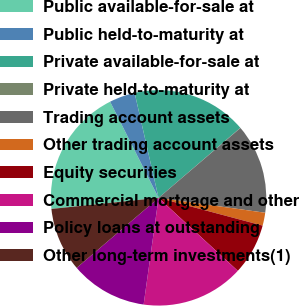<chart> <loc_0><loc_0><loc_500><loc_500><pie_chart><fcel>Public available-for-sale at<fcel>Public held-to-maturity at<fcel>Private available-for-sale at<fcel>Private held-to-maturity at<fcel>Trading account assets<fcel>Other trading account assets<fcel>Equity securities<fcel>Commercial mortgage and other<fcel>Policy loans at outstanding<fcel>Other long-term investments(1)<nl><fcel>19.21%<fcel>3.86%<fcel>17.29%<fcel>0.03%<fcel>13.45%<fcel>1.94%<fcel>7.7%<fcel>15.37%<fcel>11.53%<fcel>9.62%<nl></chart> 